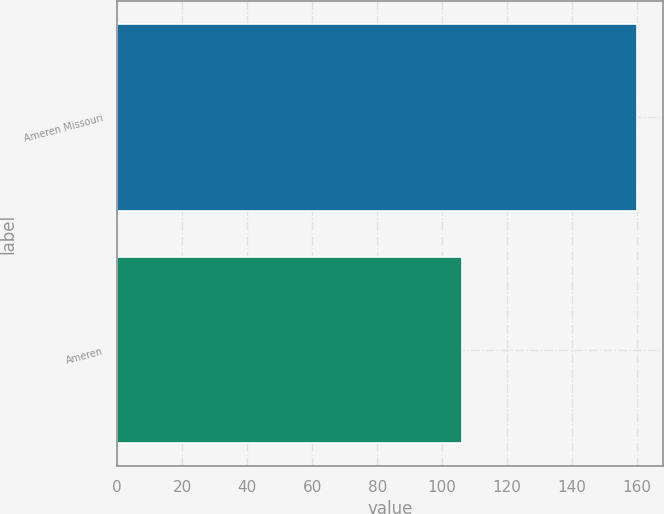Convert chart to OTSL. <chart><loc_0><loc_0><loc_500><loc_500><bar_chart><fcel>Ameren Missouri<fcel>Ameren<nl><fcel>160<fcel>106<nl></chart> 